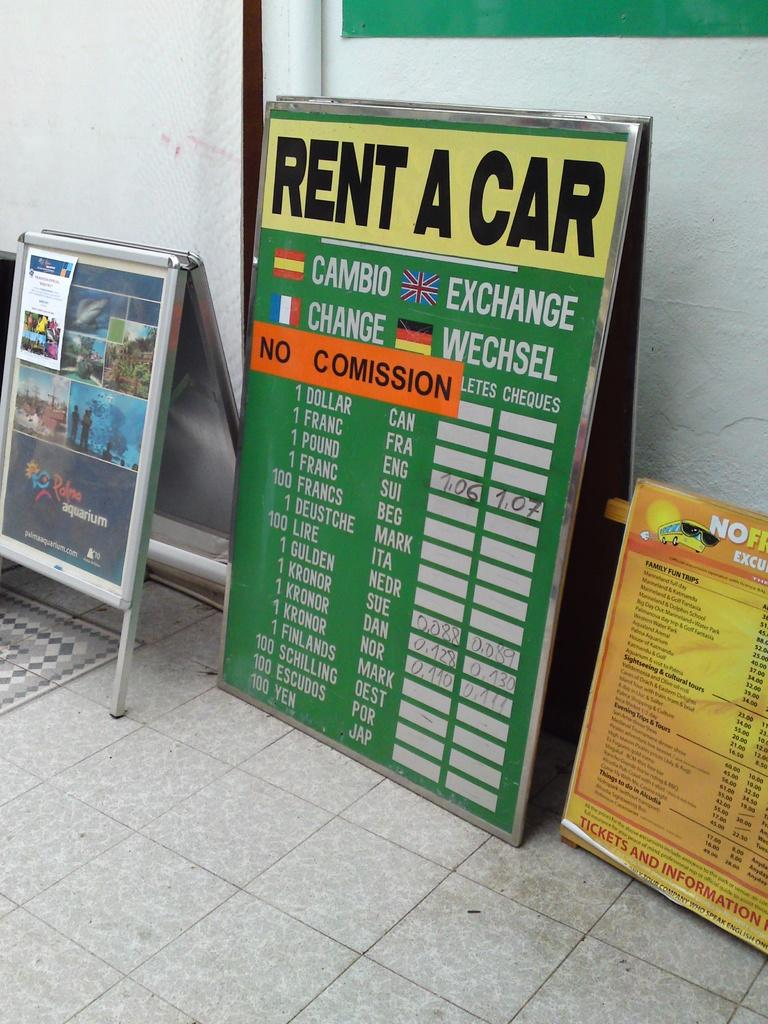<image>
Offer a succinct explanation of the picture presented. The large lists current exchange rates for various currencies like the pound and the kronor. 